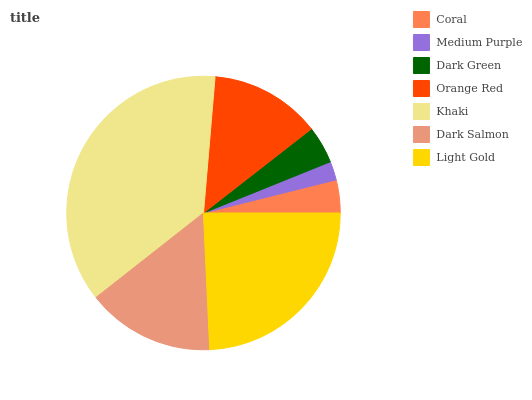Is Medium Purple the minimum?
Answer yes or no. Yes. Is Khaki the maximum?
Answer yes or no. Yes. Is Dark Green the minimum?
Answer yes or no. No. Is Dark Green the maximum?
Answer yes or no. No. Is Dark Green greater than Medium Purple?
Answer yes or no. Yes. Is Medium Purple less than Dark Green?
Answer yes or no. Yes. Is Medium Purple greater than Dark Green?
Answer yes or no. No. Is Dark Green less than Medium Purple?
Answer yes or no. No. Is Orange Red the high median?
Answer yes or no. Yes. Is Orange Red the low median?
Answer yes or no. Yes. Is Light Gold the high median?
Answer yes or no. No. Is Khaki the low median?
Answer yes or no. No. 